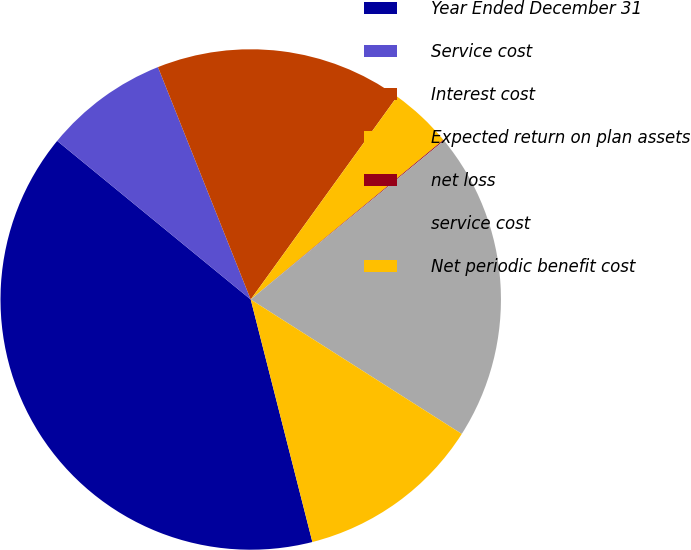Convert chart. <chart><loc_0><loc_0><loc_500><loc_500><pie_chart><fcel>Year Ended December 31<fcel>Service cost<fcel>Interest cost<fcel>Expected return on plan assets<fcel>net loss<fcel>service cost<fcel>Net periodic benefit cost<nl><fcel>39.89%<fcel>8.03%<fcel>15.99%<fcel>4.04%<fcel>0.06%<fcel>19.98%<fcel>12.01%<nl></chart> 